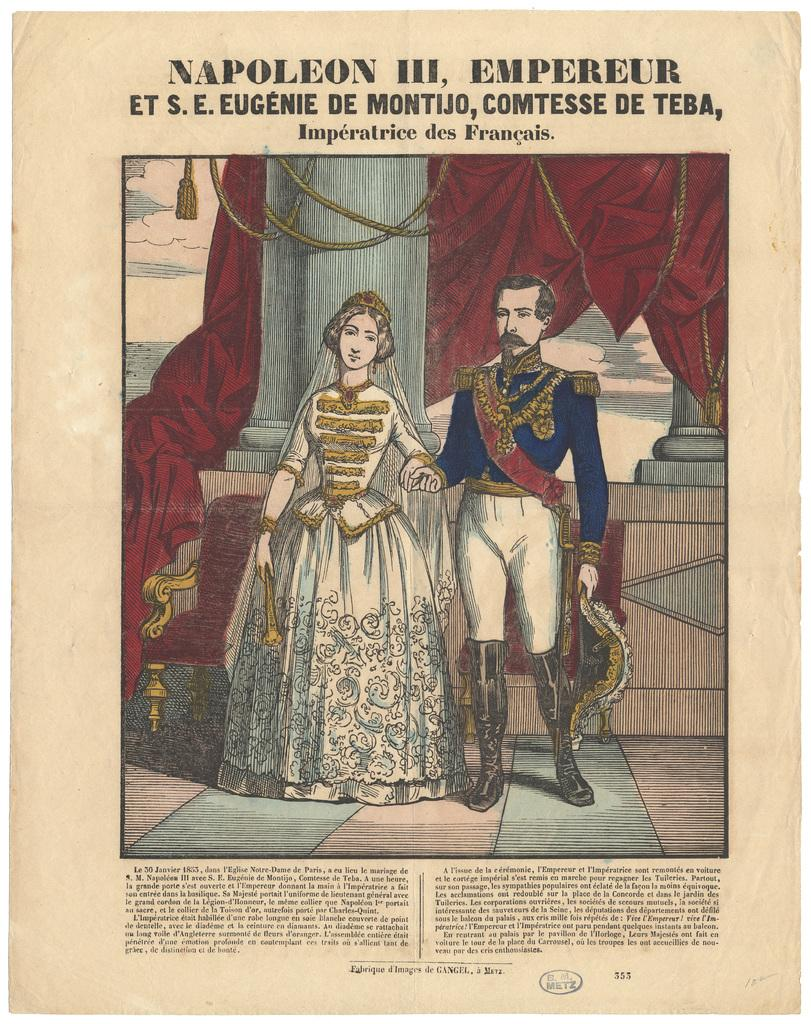What is depicted on the paper in the image? There is a painting of a king and queen on a paper. What else is present on the paper besides the painting? There is text written on the paper. What answer does the king give to the queen in the image? There is no dialogue or conversation depicted in the image, so it is not possible to determine what answer the king might give to the queen. 